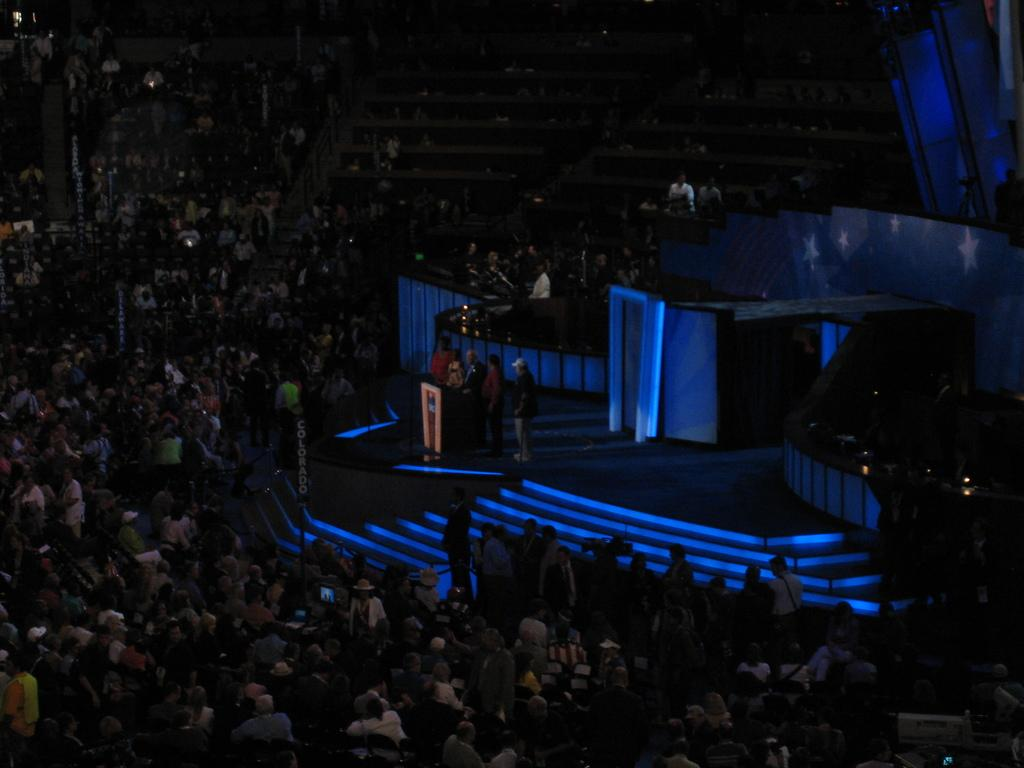What can be seen in the image? There are people in the image, along with a stage, stairs, boards, a podium, and lights. What are some people doing in the image? Some people are standing on the stage. Can you describe the stage in the image? The stage has stairs leading up to it and is equipped with a podium. What else can be seen in the image? There are lights visible in the image. How does the memory of the event affect the people in the image? There is no indication in the image that the people are affected by memories of the event, as the image only shows their current actions and surroundings. 